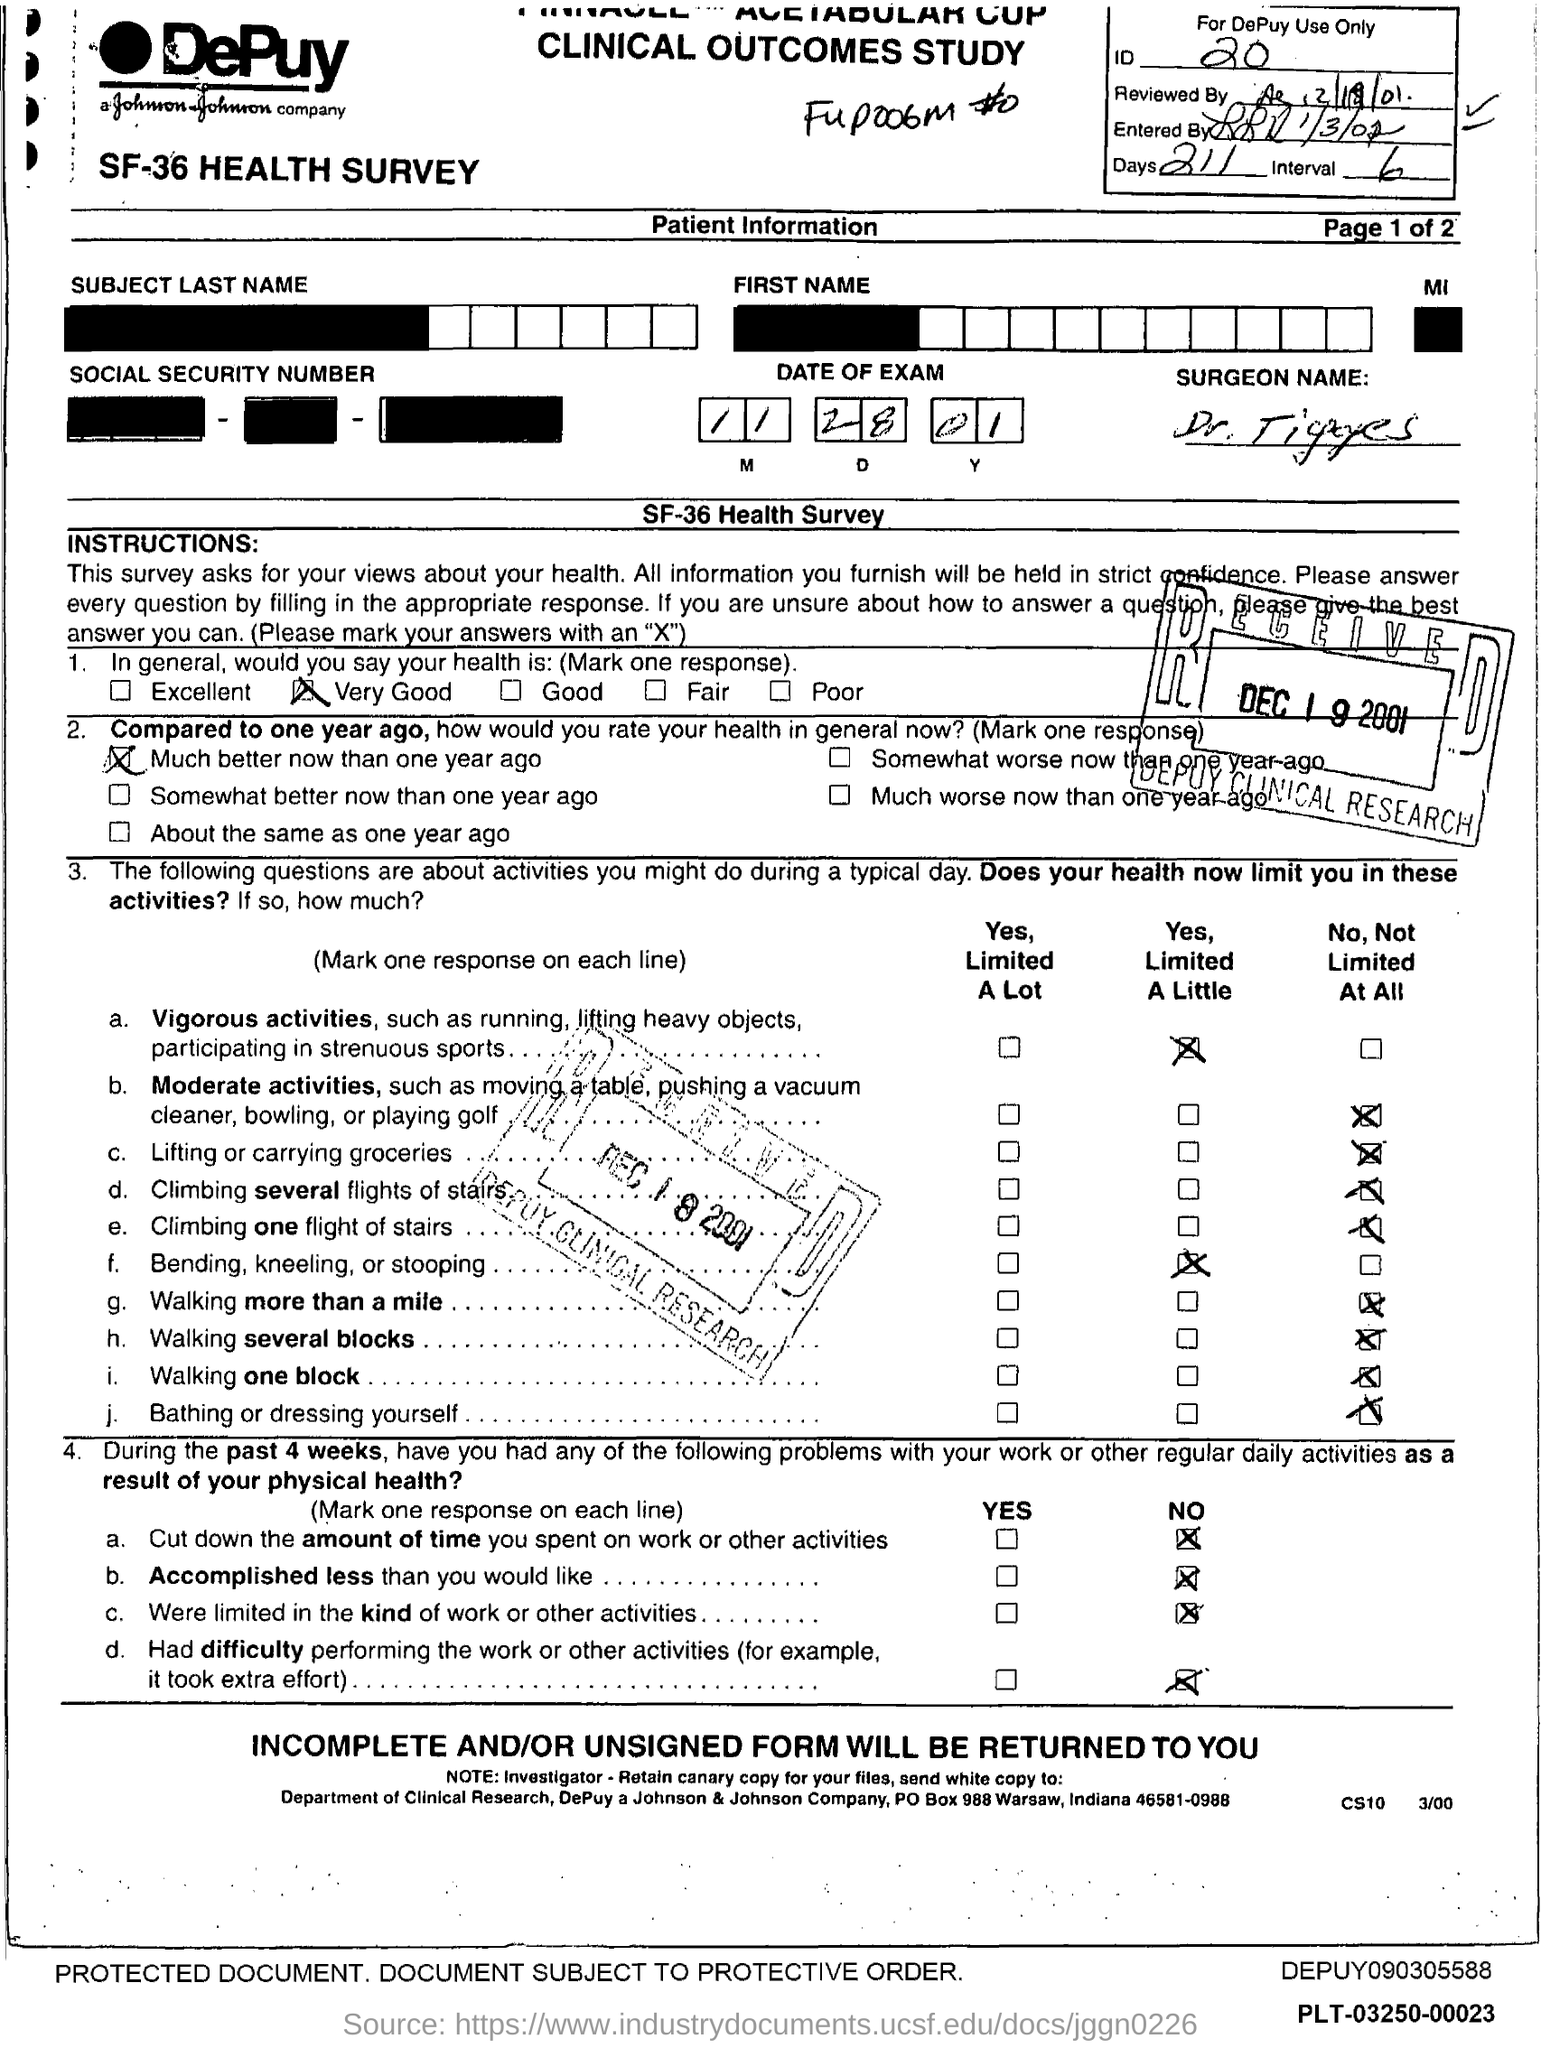Draw attention to some important aspects in this diagram. What is the identification number? It is 20... The number of days is 211. 